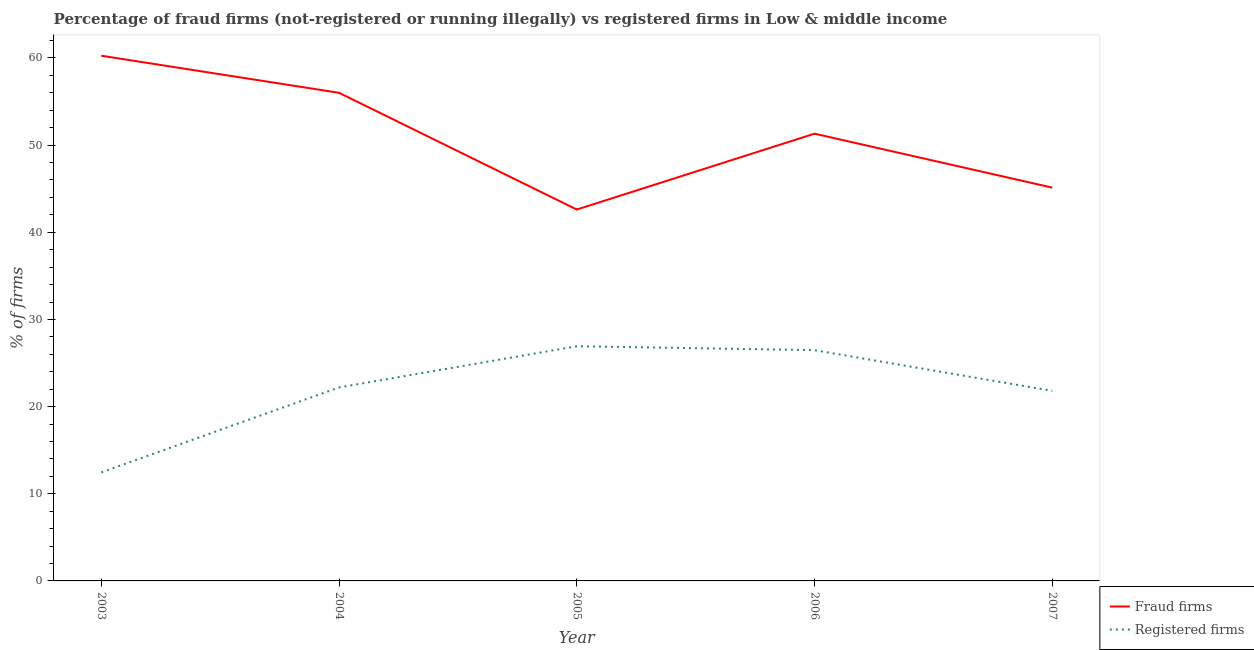Is the number of lines equal to the number of legend labels?
Keep it short and to the point. Yes. What is the percentage of fraud firms in 2007?
Your answer should be very brief. 45.12. Across all years, what is the maximum percentage of fraud firms?
Ensure brevity in your answer.  60.26. Across all years, what is the minimum percentage of registered firms?
Your answer should be very brief. 12.45. In which year was the percentage of fraud firms maximum?
Your answer should be compact. 2003. What is the total percentage of registered firms in the graph?
Your answer should be compact. 109.86. What is the difference between the percentage of fraud firms in 2005 and that in 2006?
Your answer should be compact. -8.7. What is the difference between the percentage of registered firms in 2004 and the percentage of fraud firms in 2003?
Your response must be concise. -38.06. What is the average percentage of fraud firms per year?
Your answer should be very brief. 51.06. In the year 2005, what is the difference between the percentage of fraud firms and percentage of registered firms?
Give a very brief answer. 15.68. What is the ratio of the percentage of fraud firms in 2005 to that in 2006?
Keep it short and to the point. 0.83. Is the percentage of fraud firms in 2004 less than that in 2006?
Offer a terse response. No. What is the difference between the highest and the second highest percentage of registered firms?
Make the answer very short. 0.45. What is the difference between the highest and the lowest percentage of fraud firms?
Make the answer very short. 17.65. In how many years, is the percentage of fraud firms greater than the average percentage of fraud firms taken over all years?
Provide a succinct answer. 3. Is the percentage of fraud firms strictly less than the percentage of registered firms over the years?
Your answer should be very brief. No. How many lines are there?
Make the answer very short. 2. How many years are there in the graph?
Offer a very short reply. 5. What is the difference between two consecutive major ticks on the Y-axis?
Your answer should be compact. 10. Does the graph contain any zero values?
Ensure brevity in your answer.  No. Does the graph contain grids?
Provide a succinct answer. No. How are the legend labels stacked?
Offer a terse response. Vertical. What is the title of the graph?
Ensure brevity in your answer.  Percentage of fraud firms (not-registered or running illegally) vs registered firms in Low & middle income. Does "Lower secondary rate" appear as one of the legend labels in the graph?
Offer a very short reply. No. What is the label or title of the Y-axis?
Provide a short and direct response. % of firms. What is the % of firms of Fraud firms in 2003?
Provide a succinct answer. 60.26. What is the % of firms of Registered firms in 2003?
Give a very brief answer. 12.45. What is the % of firms of Fraud firms in 2004?
Keep it short and to the point. 56.01. What is the % of firms in Fraud firms in 2005?
Offer a terse response. 42.61. What is the % of firms of Registered firms in 2005?
Your answer should be very brief. 26.93. What is the % of firms in Fraud firms in 2006?
Your answer should be very brief. 51.31. What is the % of firms in Registered firms in 2006?
Offer a terse response. 26.48. What is the % of firms of Fraud firms in 2007?
Your answer should be compact. 45.12. What is the % of firms of Registered firms in 2007?
Give a very brief answer. 21.81. Across all years, what is the maximum % of firms in Fraud firms?
Provide a succinct answer. 60.26. Across all years, what is the maximum % of firms of Registered firms?
Your response must be concise. 26.93. Across all years, what is the minimum % of firms in Fraud firms?
Your answer should be compact. 42.61. Across all years, what is the minimum % of firms of Registered firms?
Make the answer very short. 12.45. What is the total % of firms in Fraud firms in the graph?
Offer a terse response. 255.31. What is the total % of firms in Registered firms in the graph?
Your answer should be very brief. 109.86. What is the difference between the % of firms of Fraud firms in 2003 and that in 2004?
Keep it short and to the point. 4.25. What is the difference between the % of firms of Registered firms in 2003 and that in 2004?
Provide a succinct answer. -9.75. What is the difference between the % of firms of Fraud firms in 2003 and that in 2005?
Offer a very short reply. 17.65. What is the difference between the % of firms of Registered firms in 2003 and that in 2005?
Provide a short and direct response. -14.48. What is the difference between the % of firms in Fraud firms in 2003 and that in 2006?
Provide a succinct answer. 8.95. What is the difference between the % of firms of Registered firms in 2003 and that in 2006?
Your answer should be very brief. -14.03. What is the difference between the % of firms in Fraud firms in 2003 and that in 2007?
Your answer should be compact. 15.14. What is the difference between the % of firms in Registered firms in 2003 and that in 2007?
Provide a succinct answer. -9.36. What is the difference between the % of firms of Fraud firms in 2004 and that in 2005?
Give a very brief answer. 13.39. What is the difference between the % of firms in Registered firms in 2004 and that in 2005?
Ensure brevity in your answer.  -4.73. What is the difference between the % of firms of Fraud firms in 2004 and that in 2006?
Your answer should be compact. 4.69. What is the difference between the % of firms of Registered firms in 2004 and that in 2006?
Give a very brief answer. -4.28. What is the difference between the % of firms of Fraud firms in 2004 and that in 2007?
Make the answer very short. 10.88. What is the difference between the % of firms of Registered firms in 2004 and that in 2007?
Make the answer very short. 0.39. What is the difference between the % of firms in Fraud firms in 2005 and that in 2006?
Provide a short and direct response. -8.7. What is the difference between the % of firms of Registered firms in 2005 and that in 2006?
Provide a short and direct response. 0.45. What is the difference between the % of firms in Fraud firms in 2005 and that in 2007?
Your answer should be compact. -2.51. What is the difference between the % of firms in Registered firms in 2005 and that in 2007?
Provide a short and direct response. 5.12. What is the difference between the % of firms of Fraud firms in 2006 and that in 2007?
Your answer should be very brief. 6.19. What is the difference between the % of firms of Registered firms in 2006 and that in 2007?
Offer a terse response. 4.67. What is the difference between the % of firms of Fraud firms in 2003 and the % of firms of Registered firms in 2004?
Provide a succinct answer. 38.06. What is the difference between the % of firms in Fraud firms in 2003 and the % of firms in Registered firms in 2005?
Offer a very short reply. 33.33. What is the difference between the % of firms in Fraud firms in 2003 and the % of firms in Registered firms in 2006?
Provide a succinct answer. 33.78. What is the difference between the % of firms in Fraud firms in 2003 and the % of firms in Registered firms in 2007?
Your response must be concise. 38.45. What is the difference between the % of firms of Fraud firms in 2004 and the % of firms of Registered firms in 2005?
Your answer should be compact. 29.08. What is the difference between the % of firms in Fraud firms in 2004 and the % of firms in Registered firms in 2006?
Your answer should be very brief. 29.53. What is the difference between the % of firms in Fraud firms in 2004 and the % of firms in Registered firms in 2007?
Offer a terse response. 34.2. What is the difference between the % of firms in Fraud firms in 2005 and the % of firms in Registered firms in 2006?
Your answer should be compact. 16.13. What is the difference between the % of firms of Fraud firms in 2005 and the % of firms of Registered firms in 2007?
Offer a terse response. 20.8. What is the difference between the % of firms in Fraud firms in 2006 and the % of firms in Registered firms in 2007?
Give a very brief answer. 29.51. What is the average % of firms of Fraud firms per year?
Give a very brief answer. 51.06. What is the average % of firms in Registered firms per year?
Your answer should be compact. 21.97. In the year 2003, what is the difference between the % of firms in Fraud firms and % of firms in Registered firms?
Give a very brief answer. 47.81. In the year 2004, what is the difference between the % of firms of Fraud firms and % of firms of Registered firms?
Your response must be concise. 33.8. In the year 2005, what is the difference between the % of firms in Fraud firms and % of firms in Registered firms?
Your answer should be very brief. 15.68. In the year 2006, what is the difference between the % of firms of Fraud firms and % of firms of Registered firms?
Ensure brevity in your answer.  24.84. In the year 2007, what is the difference between the % of firms of Fraud firms and % of firms of Registered firms?
Your answer should be very brief. 23.32. What is the ratio of the % of firms of Fraud firms in 2003 to that in 2004?
Your response must be concise. 1.08. What is the ratio of the % of firms of Registered firms in 2003 to that in 2004?
Offer a terse response. 0.56. What is the ratio of the % of firms of Fraud firms in 2003 to that in 2005?
Provide a succinct answer. 1.41. What is the ratio of the % of firms of Registered firms in 2003 to that in 2005?
Keep it short and to the point. 0.46. What is the ratio of the % of firms of Fraud firms in 2003 to that in 2006?
Your answer should be very brief. 1.17. What is the ratio of the % of firms of Registered firms in 2003 to that in 2006?
Provide a short and direct response. 0.47. What is the ratio of the % of firms in Fraud firms in 2003 to that in 2007?
Give a very brief answer. 1.34. What is the ratio of the % of firms of Registered firms in 2003 to that in 2007?
Keep it short and to the point. 0.57. What is the ratio of the % of firms in Fraud firms in 2004 to that in 2005?
Provide a succinct answer. 1.31. What is the ratio of the % of firms in Registered firms in 2004 to that in 2005?
Provide a succinct answer. 0.82. What is the ratio of the % of firms of Fraud firms in 2004 to that in 2006?
Your answer should be compact. 1.09. What is the ratio of the % of firms of Registered firms in 2004 to that in 2006?
Give a very brief answer. 0.84. What is the ratio of the % of firms in Fraud firms in 2004 to that in 2007?
Make the answer very short. 1.24. What is the ratio of the % of firms in Registered firms in 2004 to that in 2007?
Offer a terse response. 1.02. What is the ratio of the % of firms in Fraud firms in 2005 to that in 2006?
Give a very brief answer. 0.83. What is the ratio of the % of firms in Registered firms in 2005 to that in 2006?
Your answer should be very brief. 1.02. What is the ratio of the % of firms of Fraud firms in 2005 to that in 2007?
Offer a very short reply. 0.94. What is the ratio of the % of firms of Registered firms in 2005 to that in 2007?
Ensure brevity in your answer.  1.23. What is the ratio of the % of firms in Fraud firms in 2006 to that in 2007?
Your response must be concise. 1.14. What is the ratio of the % of firms in Registered firms in 2006 to that in 2007?
Your response must be concise. 1.21. What is the difference between the highest and the second highest % of firms of Fraud firms?
Offer a terse response. 4.25. What is the difference between the highest and the second highest % of firms of Registered firms?
Your response must be concise. 0.45. What is the difference between the highest and the lowest % of firms of Fraud firms?
Your response must be concise. 17.65. What is the difference between the highest and the lowest % of firms of Registered firms?
Give a very brief answer. 14.48. 